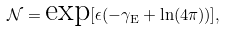<formula> <loc_0><loc_0><loc_500><loc_500>\mathcal { N } = \text {exp} [ \epsilon ( - \gamma _ { \text {E} } + \ln ( 4 \pi ) ) ] ,</formula> 